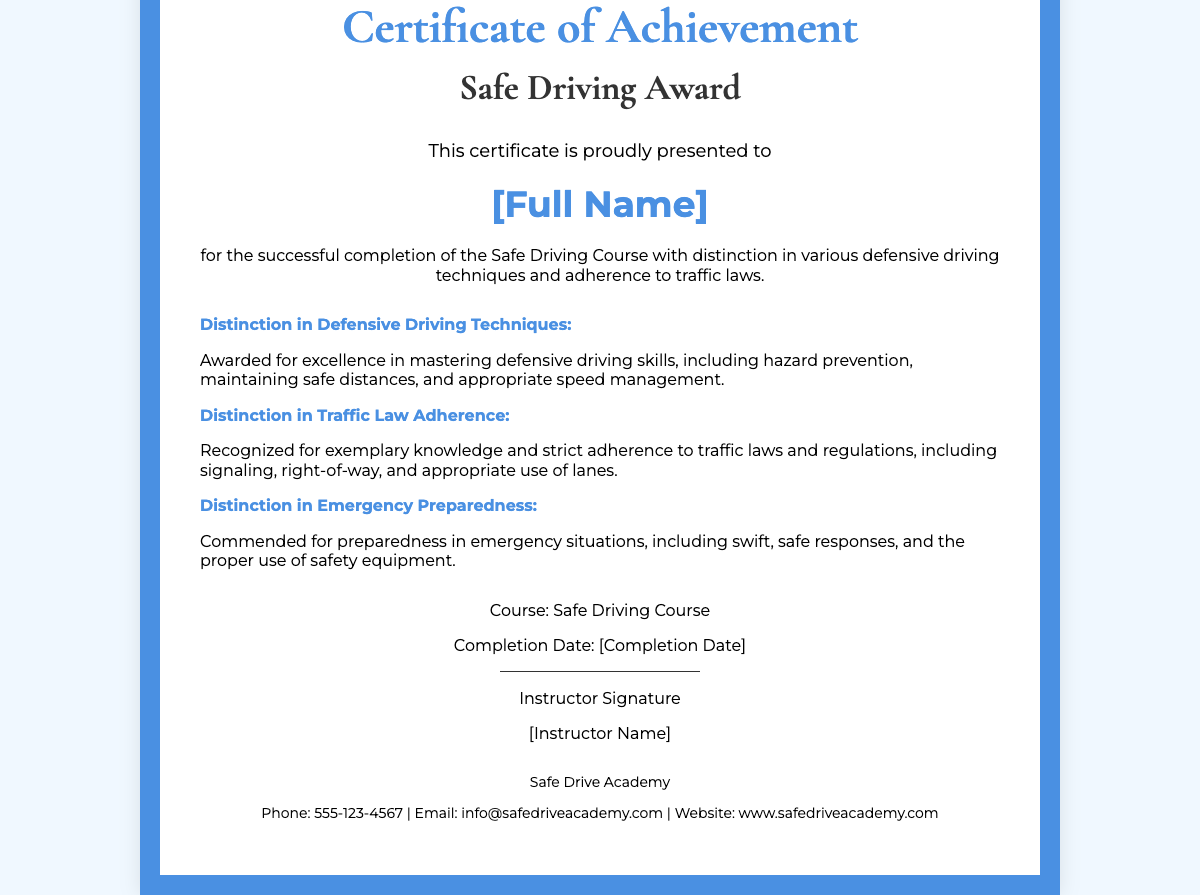What is the title of the certificate? The title is prominently displayed at the top of the document and indicates the nature of the award.
Answer: Safe Driving Award Who is the certificate presented to? The recipient's name is featured in a prominent place in the document.
Answer: [Full Name] What is the completion date of the course? The completion date is specifically noted in the document's footer.
Answer: [Completion Date] Which organization issued the certificate? The issuing organization is mentioned at the bottom of the document.
Answer: Safe Drive Academy What is one of the distinctions awarded? This distinction is listed in a section dedicated to the achievements of the recipient.
Answer: Distinction in Defensive Driving Techniques What is included in the instructor's information? The document provides a space for the instructor's signature and name, which is important for validation.
Answer: [Instructor Name] How many distinctions are awarded? The document lists several distinctions, showcasing the recipient's skills.
Answer: Three What type of course was completed? The document specifies the type of education or training completed by the recipient.
Answer: Safe Driving Course What is the contact number for the issuing organization? The document includes a contact number for inquiries related to the certificate.
Answer: 555-123-4567 